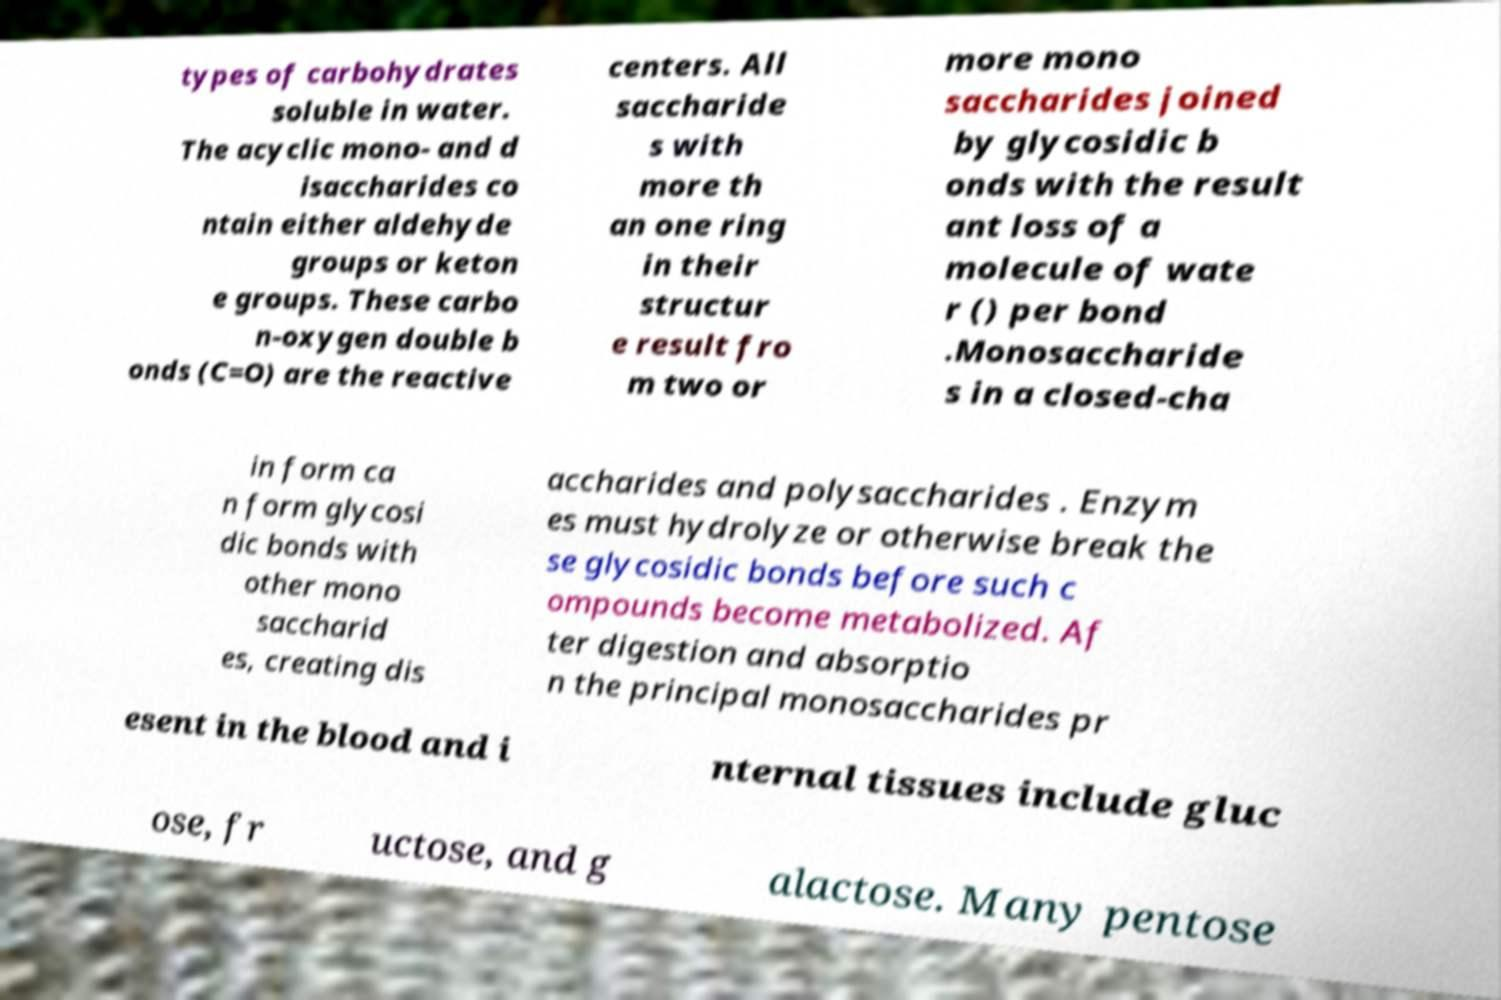There's text embedded in this image that I need extracted. Can you transcribe it verbatim? types of carbohydrates soluble in water. The acyclic mono- and d isaccharides co ntain either aldehyde groups or keton e groups. These carbo n-oxygen double b onds (C=O) are the reactive centers. All saccharide s with more th an one ring in their structur e result fro m two or more mono saccharides joined by glycosidic b onds with the result ant loss of a molecule of wate r () per bond .Monosaccharide s in a closed-cha in form ca n form glycosi dic bonds with other mono saccharid es, creating dis accharides and polysaccharides . Enzym es must hydrolyze or otherwise break the se glycosidic bonds before such c ompounds become metabolized. Af ter digestion and absorptio n the principal monosaccharides pr esent in the blood and i nternal tissues include gluc ose, fr uctose, and g alactose. Many pentose 